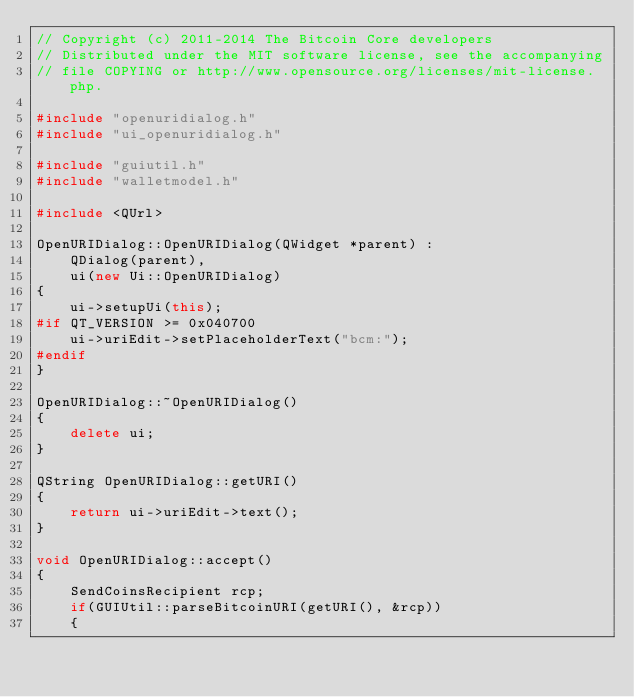<code> <loc_0><loc_0><loc_500><loc_500><_C++_>// Copyright (c) 2011-2014 The Bitcoin Core developers
// Distributed under the MIT software license, see the accompanying
// file COPYING or http://www.opensource.org/licenses/mit-license.php.

#include "openuridialog.h"
#include "ui_openuridialog.h"

#include "guiutil.h"
#include "walletmodel.h"

#include <QUrl>

OpenURIDialog::OpenURIDialog(QWidget *parent) :
    QDialog(parent),
    ui(new Ui::OpenURIDialog)
{
    ui->setupUi(this);
#if QT_VERSION >= 0x040700
    ui->uriEdit->setPlaceholderText("bcm:");
#endif
}

OpenURIDialog::~OpenURIDialog()
{
    delete ui;
}

QString OpenURIDialog::getURI()
{
    return ui->uriEdit->text();
}

void OpenURIDialog::accept()
{
    SendCoinsRecipient rcp;
    if(GUIUtil::parseBitcoinURI(getURI(), &rcp))
    {</code> 